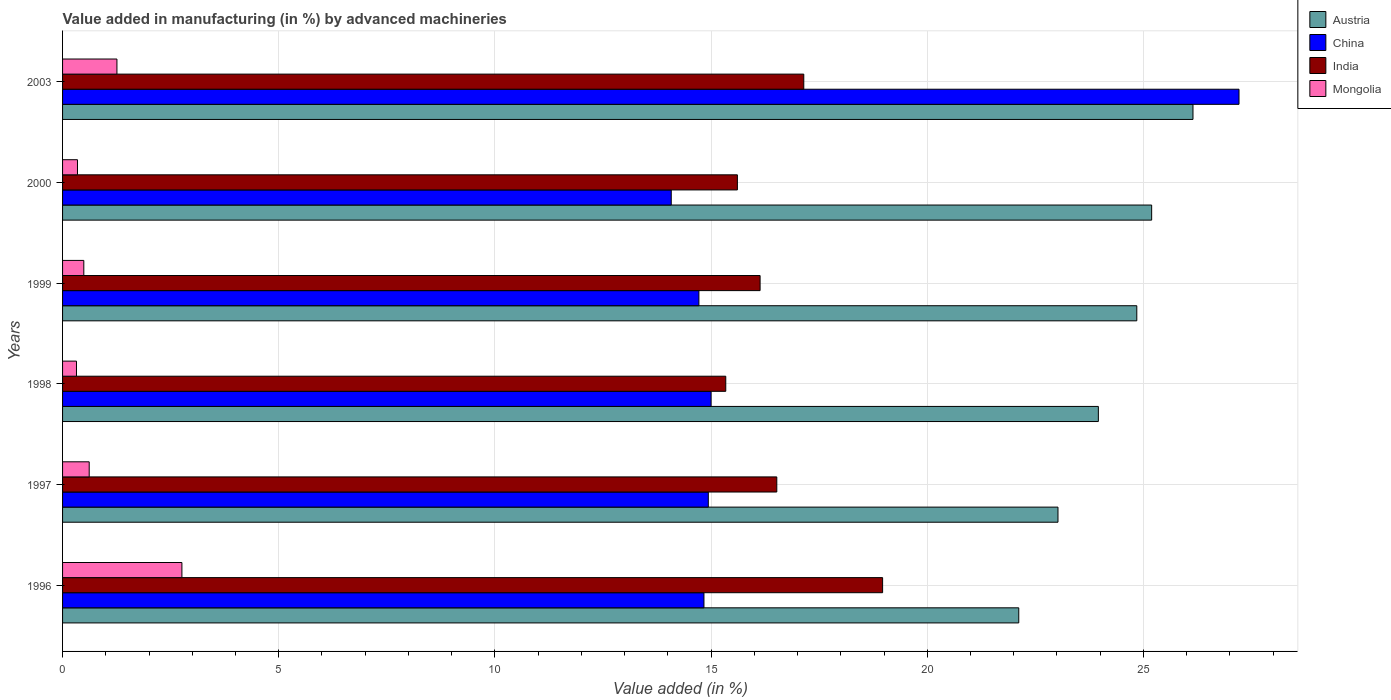How many different coloured bars are there?
Keep it short and to the point. 4. Are the number of bars on each tick of the Y-axis equal?
Provide a succinct answer. Yes. How many bars are there on the 4th tick from the top?
Offer a terse response. 4. What is the percentage of value added in manufacturing by advanced machineries in India in 1998?
Provide a succinct answer. 15.34. Across all years, what is the maximum percentage of value added in manufacturing by advanced machineries in Austria?
Give a very brief answer. 26.15. Across all years, what is the minimum percentage of value added in manufacturing by advanced machineries in India?
Give a very brief answer. 15.34. In which year was the percentage of value added in manufacturing by advanced machineries in China maximum?
Ensure brevity in your answer.  2003. What is the total percentage of value added in manufacturing by advanced machineries in Austria in the graph?
Provide a short and direct response. 145.28. What is the difference between the percentage of value added in manufacturing by advanced machineries in Austria in 1996 and that in 1997?
Your response must be concise. -0.91. What is the difference between the percentage of value added in manufacturing by advanced machineries in China in 2000 and the percentage of value added in manufacturing by advanced machineries in Mongolia in 1999?
Your answer should be compact. 13.59. What is the average percentage of value added in manufacturing by advanced machineries in Mongolia per year?
Provide a short and direct response. 0.97. In the year 1999, what is the difference between the percentage of value added in manufacturing by advanced machineries in Austria and percentage of value added in manufacturing by advanced machineries in India?
Offer a very short reply. 8.71. In how many years, is the percentage of value added in manufacturing by advanced machineries in China greater than 9 %?
Your answer should be compact. 6. What is the ratio of the percentage of value added in manufacturing by advanced machineries in Austria in 1998 to that in 2000?
Your response must be concise. 0.95. What is the difference between the highest and the second highest percentage of value added in manufacturing by advanced machineries in Austria?
Provide a succinct answer. 0.96. What is the difference between the highest and the lowest percentage of value added in manufacturing by advanced machineries in China?
Offer a terse response. 13.13. Is the sum of the percentage of value added in manufacturing by advanced machineries in China in 1997 and 1999 greater than the maximum percentage of value added in manufacturing by advanced machineries in Mongolia across all years?
Your response must be concise. Yes. What does the 1st bar from the top in 1998 represents?
Offer a very short reply. Mongolia. Are all the bars in the graph horizontal?
Provide a short and direct response. Yes. Does the graph contain any zero values?
Offer a very short reply. No. Does the graph contain grids?
Make the answer very short. Yes. Where does the legend appear in the graph?
Make the answer very short. Top right. How are the legend labels stacked?
Keep it short and to the point. Vertical. What is the title of the graph?
Offer a very short reply. Value added in manufacturing (in %) by advanced machineries. Does "Poland" appear as one of the legend labels in the graph?
Offer a terse response. No. What is the label or title of the X-axis?
Keep it short and to the point. Value added (in %). What is the Value added (in %) of Austria in 1996?
Offer a very short reply. 22.12. What is the Value added (in %) of China in 1996?
Offer a very short reply. 14.84. What is the Value added (in %) of India in 1996?
Make the answer very short. 18.97. What is the Value added (in %) of Mongolia in 1996?
Ensure brevity in your answer.  2.76. What is the Value added (in %) in Austria in 1997?
Keep it short and to the point. 23.02. What is the Value added (in %) in China in 1997?
Make the answer very short. 14.94. What is the Value added (in %) of India in 1997?
Your answer should be compact. 16.52. What is the Value added (in %) in Mongolia in 1997?
Your response must be concise. 0.62. What is the Value added (in %) of Austria in 1998?
Give a very brief answer. 23.96. What is the Value added (in %) of China in 1998?
Offer a very short reply. 15. What is the Value added (in %) in India in 1998?
Give a very brief answer. 15.34. What is the Value added (in %) in Mongolia in 1998?
Make the answer very short. 0.32. What is the Value added (in %) in Austria in 1999?
Give a very brief answer. 24.85. What is the Value added (in %) of China in 1999?
Offer a very short reply. 14.72. What is the Value added (in %) of India in 1999?
Offer a terse response. 16.13. What is the Value added (in %) of Mongolia in 1999?
Keep it short and to the point. 0.49. What is the Value added (in %) of Austria in 2000?
Offer a terse response. 25.19. What is the Value added (in %) in China in 2000?
Offer a terse response. 14.08. What is the Value added (in %) of India in 2000?
Ensure brevity in your answer.  15.61. What is the Value added (in %) of Mongolia in 2000?
Make the answer very short. 0.34. What is the Value added (in %) in Austria in 2003?
Your answer should be very brief. 26.15. What is the Value added (in %) of China in 2003?
Provide a short and direct response. 27.21. What is the Value added (in %) of India in 2003?
Offer a terse response. 17.14. What is the Value added (in %) of Mongolia in 2003?
Your answer should be compact. 1.26. Across all years, what is the maximum Value added (in %) in Austria?
Your answer should be very brief. 26.15. Across all years, what is the maximum Value added (in %) in China?
Your answer should be compact. 27.21. Across all years, what is the maximum Value added (in %) in India?
Keep it short and to the point. 18.97. Across all years, what is the maximum Value added (in %) in Mongolia?
Make the answer very short. 2.76. Across all years, what is the minimum Value added (in %) of Austria?
Keep it short and to the point. 22.12. Across all years, what is the minimum Value added (in %) in China?
Your answer should be very brief. 14.08. Across all years, what is the minimum Value added (in %) in India?
Keep it short and to the point. 15.34. Across all years, what is the minimum Value added (in %) in Mongolia?
Offer a terse response. 0.32. What is the total Value added (in %) in Austria in the graph?
Ensure brevity in your answer.  145.28. What is the total Value added (in %) of China in the graph?
Your response must be concise. 100.78. What is the total Value added (in %) of India in the graph?
Provide a short and direct response. 99.72. What is the total Value added (in %) in Mongolia in the graph?
Your answer should be compact. 5.79. What is the difference between the Value added (in %) in Austria in 1996 and that in 1997?
Give a very brief answer. -0.91. What is the difference between the Value added (in %) of China in 1996 and that in 1997?
Provide a short and direct response. -0.1. What is the difference between the Value added (in %) in India in 1996 and that in 1997?
Give a very brief answer. 2.45. What is the difference between the Value added (in %) of Mongolia in 1996 and that in 1997?
Offer a terse response. 2.14. What is the difference between the Value added (in %) of Austria in 1996 and that in 1998?
Your answer should be very brief. -1.84. What is the difference between the Value added (in %) in China in 1996 and that in 1998?
Keep it short and to the point. -0.17. What is the difference between the Value added (in %) of India in 1996 and that in 1998?
Offer a terse response. 3.63. What is the difference between the Value added (in %) in Mongolia in 1996 and that in 1998?
Your response must be concise. 2.44. What is the difference between the Value added (in %) of Austria in 1996 and that in 1999?
Offer a terse response. -2.73. What is the difference between the Value added (in %) in China in 1996 and that in 1999?
Provide a succinct answer. 0.12. What is the difference between the Value added (in %) of India in 1996 and that in 1999?
Provide a succinct answer. 2.83. What is the difference between the Value added (in %) in Mongolia in 1996 and that in 1999?
Your answer should be compact. 2.27. What is the difference between the Value added (in %) in Austria in 1996 and that in 2000?
Give a very brief answer. -3.07. What is the difference between the Value added (in %) in China in 1996 and that in 2000?
Offer a very short reply. 0.76. What is the difference between the Value added (in %) of India in 1996 and that in 2000?
Make the answer very short. 3.36. What is the difference between the Value added (in %) in Mongolia in 1996 and that in 2000?
Make the answer very short. 2.42. What is the difference between the Value added (in %) in Austria in 1996 and that in 2003?
Ensure brevity in your answer.  -4.03. What is the difference between the Value added (in %) of China in 1996 and that in 2003?
Give a very brief answer. -12.38. What is the difference between the Value added (in %) of India in 1996 and that in 2003?
Keep it short and to the point. 1.82. What is the difference between the Value added (in %) in Mongolia in 1996 and that in 2003?
Your answer should be very brief. 1.5. What is the difference between the Value added (in %) of Austria in 1997 and that in 1998?
Provide a short and direct response. -0.93. What is the difference between the Value added (in %) in China in 1997 and that in 1998?
Give a very brief answer. -0.06. What is the difference between the Value added (in %) in India in 1997 and that in 1998?
Provide a short and direct response. 1.18. What is the difference between the Value added (in %) of Mongolia in 1997 and that in 1998?
Provide a short and direct response. 0.29. What is the difference between the Value added (in %) of Austria in 1997 and that in 1999?
Offer a very short reply. -1.82. What is the difference between the Value added (in %) in China in 1997 and that in 1999?
Offer a terse response. 0.22. What is the difference between the Value added (in %) in India in 1997 and that in 1999?
Offer a terse response. 0.39. What is the difference between the Value added (in %) in Mongolia in 1997 and that in 1999?
Provide a succinct answer. 0.12. What is the difference between the Value added (in %) of Austria in 1997 and that in 2000?
Keep it short and to the point. -2.17. What is the difference between the Value added (in %) in China in 1997 and that in 2000?
Keep it short and to the point. 0.86. What is the difference between the Value added (in %) of India in 1997 and that in 2000?
Give a very brief answer. 0.91. What is the difference between the Value added (in %) of Mongolia in 1997 and that in 2000?
Provide a succinct answer. 0.27. What is the difference between the Value added (in %) of Austria in 1997 and that in 2003?
Offer a very short reply. -3.12. What is the difference between the Value added (in %) of China in 1997 and that in 2003?
Provide a short and direct response. -12.28. What is the difference between the Value added (in %) in India in 1997 and that in 2003?
Keep it short and to the point. -0.62. What is the difference between the Value added (in %) in Mongolia in 1997 and that in 2003?
Give a very brief answer. -0.64. What is the difference between the Value added (in %) of Austria in 1998 and that in 1999?
Your answer should be compact. -0.89. What is the difference between the Value added (in %) in China in 1998 and that in 1999?
Give a very brief answer. 0.28. What is the difference between the Value added (in %) in India in 1998 and that in 1999?
Ensure brevity in your answer.  -0.79. What is the difference between the Value added (in %) in Mongolia in 1998 and that in 1999?
Offer a very short reply. -0.17. What is the difference between the Value added (in %) in Austria in 1998 and that in 2000?
Ensure brevity in your answer.  -1.23. What is the difference between the Value added (in %) in China in 1998 and that in 2000?
Your answer should be very brief. 0.92. What is the difference between the Value added (in %) in India in 1998 and that in 2000?
Give a very brief answer. -0.27. What is the difference between the Value added (in %) in Mongolia in 1998 and that in 2000?
Keep it short and to the point. -0.02. What is the difference between the Value added (in %) of Austria in 1998 and that in 2003?
Ensure brevity in your answer.  -2.19. What is the difference between the Value added (in %) in China in 1998 and that in 2003?
Ensure brevity in your answer.  -12.21. What is the difference between the Value added (in %) in India in 1998 and that in 2003?
Provide a succinct answer. -1.8. What is the difference between the Value added (in %) of Mongolia in 1998 and that in 2003?
Provide a succinct answer. -0.94. What is the difference between the Value added (in %) of Austria in 1999 and that in 2000?
Keep it short and to the point. -0.34. What is the difference between the Value added (in %) of China in 1999 and that in 2000?
Ensure brevity in your answer.  0.64. What is the difference between the Value added (in %) in India in 1999 and that in 2000?
Keep it short and to the point. 0.53. What is the difference between the Value added (in %) in Mongolia in 1999 and that in 2000?
Your answer should be compact. 0.15. What is the difference between the Value added (in %) of Austria in 1999 and that in 2003?
Give a very brief answer. -1.3. What is the difference between the Value added (in %) in China in 1999 and that in 2003?
Provide a succinct answer. -12.49. What is the difference between the Value added (in %) of India in 1999 and that in 2003?
Your answer should be very brief. -1.01. What is the difference between the Value added (in %) of Mongolia in 1999 and that in 2003?
Offer a very short reply. -0.77. What is the difference between the Value added (in %) of Austria in 2000 and that in 2003?
Give a very brief answer. -0.96. What is the difference between the Value added (in %) in China in 2000 and that in 2003?
Make the answer very short. -13.13. What is the difference between the Value added (in %) of India in 2000 and that in 2003?
Give a very brief answer. -1.54. What is the difference between the Value added (in %) of Mongolia in 2000 and that in 2003?
Offer a terse response. -0.91. What is the difference between the Value added (in %) of Austria in 1996 and the Value added (in %) of China in 1997?
Offer a very short reply. 7.18. What is the difference between the Value added (in %) in Austria in 1996 and the Value added (in %) in India in 1997?
Your answer should be compact. 5.6. What is the difference between the Value added (in %) in Austria in 1996 and the Value added (in %) in Mongolia in 1997?
Provide a succinct answer. 21.5. What is the difference between the Value added (in %) of China in 1996 and the Value added (in %) of India in 1997?
Keep it short and to the point. -1.68. What is the difference between the Value added (in %) of China in 1996 and the Value added (in %) of Mongolia in 1997?
Offer a very short reply. 14.22. What is the difference between the Value added (in %) in India in 1996 and the Value added (in %) in Mongolia in 1997?
Provide a short and direct response. 18.35. What is the difference between the Value added (in %) of Austria in 1996 and the Value added (in %) of China in 1998?
Your response must be concise. 7.12. What is the difference between the Value added (in %) in Austria in 1996 and the Value added (in %) in India in 1998?
Your answer should be very brief. 6.78. What is the difference between the Value added (in %) in Austria in 1996 and the Value added (in %) in Mongolia in 1998?
Give a very brief answer. 21.8. What is the difference between the Value added (in %) of China in 1996 and the Value added (in %) of India in 1998?
Keep it short and to the point. -0.5. What is the difference between the Value added (in %) in China in 1996 and the Value added (in %) in Mongolia in 1998?
Offer a very short reply. 14.51. What is the difference between the Value added (in %) in India in 1996 and the Value added (in %) in Mongolia in 1998?
Ensure brevity in your answer.  18.65. What is the difference between the Value added (in %) of Austria in 1996 and the Value added (in %) of China in 1999?
Your response must be concise. 7.4. What is the difference between the Value added (in %) in Austria in 1996 and the Value added (in %) in India in 1999?
Offer a terse response. 5.98. What is the difference between the Value added (in %) of Austria in 1996 and the Value added (in %) of Mongolia in 1999?
Provide a short and direct response. 21.63. What is the difference between the Value added (in %) in China in 1996 and the Value added (in %) in India in 1999?
Offer a terse response. -1.3. What is the difference between the Value added (in %) of China in 1996 and the Value added (in %) of Mongolia in 1999?
Ensure brevity in your answer.  14.34. What is the difference between the Value added (in %) in India in 1996 and the Value added (in %) in Mongolia in 1999?
Keep it short and to the point. 18.48. What is the difference between the Value added (in %) of Austria in 1996 and the Value added (in %) of China in 2000?
Keep it short and to the point. 8.04. What is the difference between the Value added (in %) in Austria in 1996 and the Value added (in %) in India in 2000?
Ensure brevity in your answer.  6.51. What is the difference between the Value added (in %) of Austria in 1996 and the Value added (in %) of Mongolia in 2000?
Provide a short and direct response. 21.77. What is the difference between the Value added (in %) of China in 1996 and the Value added (in %) of India in 2000?
Give a very brief answer. -0.77. What is the difference between the Value added (in %) of China in 1996 and the Value added (in %) of Mongolia in 2000?
Your answer should be very brief. 14.49. What is the difference between the Value added (in %) in India in 1996 and the Value added (in %) in Mongolia in 2000?
Make the answer very short. 18.62. What is the difference between the Value added (in %) in Austria in 1996 and the Value added (in %) in China in 2003?
Make the answer very short. -5.09. What is the difference between the Value added (in %) of Austria in 1996 and the Value added (in %) of India in 2003?
Ensure brevity in your answer.  4.97. What is the difference between the Value added (in %) in Austria in 1996 and the Value added (in %) in Mongolia in 2003?
Make the answer very short. 20.86. What is the difference between the Value added (in %) of China in 1996 and the Value added (in %) of India in 2003?
Provide a short and direct response. -2.31. What is the difference between the Value added (in %) of China in 1996 and the Value added (in %) of Mongolia in 2003?
Your answer should be compact. 13.58. What is the difference between the Value added (in %) of India in 1996 and the Value added (in %) of Mongolia in 2003?
Provide a short and direct response. 17.71. What is the difference between the Value added (in %) in Austria in 1997 and the Value added (in %) in China in 1998?
Provide a succinct answer. 8.02. What is the difference between the Value added (in %) of Austria in 1997 and the Value added (in %) of India in 1998?
Your response must be concise. 7.68. What is the difference between the Value added (in %) in Austria in 1997 and the Value added (in %) in Mongolia in 1998?
Offer a terse response. 22.7. What is the difference between the Value added (in %) of China in 1997 and the Value added (in %) of India in 1998?
Your response must be concise. -0.4. What is the difference between the Value added (in %) in China in 1997 and the Value added (in %) in Mongolia in 1998?
Provide a succinct answer. 14.61. What is the difference between the Value added (in %) in India in 1997 and the Value added (in %) in Mongolia in 1998?
Make the answer very short. 16.2. What is the difference between the Value added (in %) of Austria in 1997 and the Value added (in %) of China in 1999?
Offer a terse response. 8.31. What is the difference between the Value added (in %) of Austria in 1997 and the Value added (in %) of India in 1999?
Provide a short and direct response. 6.89. What is the difference between the Value added (in %) of Austria in 1997 and the Value added (in %) of Mongolia in 1999?
Offer a terse response. 22.53. What is the difference between the Value added (in %) in China in 1997 and the Value added (in %) in India in 1999?
Provide a short and direct response. -1.2. What is the difference between the Value added (in %) in China in 1997 and the Value added (in %) in Mongolia in 1999?
Offer a very short reply. 14.44. What is the difference between the Value added (in %) in India in 1997 and the Value added (in %) in Mongolia in 1999?
Ensure brevity in your answer.  16.03. What is the difference between the Value added (in %) in Austria in 1997 and the Value added (in %) in China in 2000?
Your response must be concise. 8.95. What is the difference between the Value added (in %) of Austria in 1997 and the Value added (in %) of India in 2000?
Give a very brief answer. 7.42. What is the difference between the Value added (in %) in Austria in 1997 and the Value added (in %) in Mongolia in 2000?
Keep it short and to the point. 22.68. What is the difference between the Value added (in %) in China in 1997 and the Value added (in %) in India in 2000?
Offer a terse response. -0.67. What is the difference between the Value added (in %) of China in 1997 and the Value added (in %) of Mongolia in 2000?
Offer a terse response. 14.59. What is the difference between the Value added (in %) in India in 1997 and the Value added (in %) in Mongolia in 2000?
Provide a short and direct response. 16.18. What is the difference between the Value added (in %) of Austria in 1997 and the Value added (in %) of China in 2003?
Your response must be concise. -4.19. What is the difference between the Value added (in %) of Austria in 1997 and the Value added (in %) of India in 2003?
Provide a short and direct response. 5.88. What is the difference between the Value added (in %) in Austria in 1997 and the Value added (in %) in Mongolia in 2003?
Your answer should be very brief. 21.77. What is the difference between the Value added (in %) of China in 1997 and the Value added (in %) of India in 2003?
Make the answer very short. -2.21. What is the difference between the Value added (in %) in China in 1997 and the Value added (in %) in Mongolia in 2003?
Your answer should be very brief. 13.68. What is the difference between the Value added (in %) in India in 1997 and the Value added (in %) in Mongolia in 2003?
Give a very brief answer. 15.26. What is the difference between the Value added (in %) in Austria in 1998 and the Value added (in %) in China in 1999?
Make the answer very short. 9.24. What is the difference between the Value added (in %) in Austria in 1998 and the Value added (in %) in India in 1999?
Your answer should be compact. 7.82. What is the difference between the Value added (in %) of Austria in 1998 and the Value added (in %) of Mongolia in 1999?
Give a very brief answer. 23.47. What is the difference between the Value added (in %) in China in 1998 and the Value added (in %) in India in 1999?
Make the answer very short. -1.13. What is the difference between the Value added (in %) of China in 1998 and the Value added (in %) of Mongolia in 1999?
Make the answer very short. 14.51. What is the difference between the Value added (in %) in India in 1998 and the Value added (in %) in Mongolia in 1999?
Provide a short and direct response. 14.85. What is the difference between the Value added (in %) in Austria in 1998 and the Value added (in %) in China in 2000?
Give a very brief answer. 9.88. What is the difference between the Value added (in %) of Austria in 1998 and the Value added (in %) of India in 2000?
Provide a short and direct response. 8.35. What is the difference between the Value added (in %) of Austria in 1998 and the Value added (in %) of Mongolia in 2000?
Make the answer very short. 23.61. What is the difference between the Value added (in %) of China in 1998 and the Value added (in %) of India in 2000?
Offer a very short reply. -0.61. What is the difference between the Value added (in %) in China in 1998 and the Value added (in %) in Mongolia in 2000?
Give a very brief answer. 14.66. What is the difference between the Value added (in %) in India in 1998 and the Value added (in %) in Mongolia in 2000?
Your response must be concise. 14.99. What is the difference between the Value added (in %) of Austria in 1998 and the Value added (in %) of China in 2003?
Keep it short and to the point. -3.25. What is the difference between the Value added (in %) of Austria in 1998 and the Value added (in %) of India in 2003?
Offer a terse response. 6.81. What is the difference between the Value added (in %) in Austria in 1998 and the Value added (in %) in Mongolia in 2003?
Provide a short and direct response. 22.7. What is the difference between the Value added (in %) in China in 1998 and the Value added (in %) in India in 2003?
Make the answer very short. -2.14. What is the difference between the Value added (in %) in China in 1998 and the Value added (in %) in Mongolia in 2003?
Give a very brief answer. 13.74. What is the difference between the Value added (in %) in India in 1998 and the Value added (in %) in Mongolia in 2003?
Provide a succinct answer. 14.08. What is the difference between the Value added (in %) in Austria in 1999 and the Value added (in %) in China in 2000?
Provide a short and direct response. 10.77. What is the difference between the Value added (in %) of Austria in 1999 and the Value added (in %) of India in 2000?
Your response must be concise. 9.24. What is the difference between the Value added (in %) in Austria in 1999 and the Value added (in %) in Mongolia in 2000?
Provide a short and direct response. 24.5. What is the difference between the Value added (in %) of China in 1999 and the Value added (in %) of India in 2000?
Provide a succinct answer. -0.89. What is the difference between the Value added (in %) of China in 1999 and the Value added (in %) of Mongolia in 2000?
Your response must be concise. 14.37. What is the difference between the Value added (in %) in India in 1999 and the Value added (in %) in Mongolia in 2000?
Provide a succinct answer. 15.79. What is the difference between the Value added (in %) in Austria in 1999 and the Value added (in %) in China in 2003?
Provide a short and direct response. -2.36. What is the difference between the Value added (in %) of Austria in 1999 and the Value added (in %) of India in 2003?
Provide a short and direct response. 7.7. What is the difference between the Value added (in %) in Austria in 1999 and the Value added (in %) in Mongolia in 2003?
Ensure brevity in your answer.  23.59. What is the difference between the Value added (in %) of China in 1999 and the Value added (in %) of India in 2003?
Make the answer very short. -2.43. What is the difference between the Value added (in %) in China in 1999 and the Value added (in %) in Mongolia in 2003?
Offer a terse response. 13.46. What is the difference between the Value added (in %) in India in 1999 and the Value added (in %) in Mongolia in 2003?
Your answer should be very brief. 14.88. What is the difference between the Value added (in %) in Austria in 2000 and the Value added (in %) in China in 2003?
Offer a terse response. -2.02. What is the difference between the Value added (in %) in Austria in 2000 and the Value added (in %) in India in 2003?
Offer a very short reply. 8.05. What is the difference between the Value added (in %) of Austria in 2000 and the Value added (in %) of Mongolia in 2003?
Offer a very short reply. 23.93. What is the difference between the Value added (in %) in China in 2000 and the Value added (in %) in India in 2003?
Make the answer very short. -3.07. What is the difference between the Value added (in %) in China in 2000 and the Value added (in %) in Mongolia in 2003?
Offer a terse response. 12.82. What is the difference between the Value added (in %) of India in 2000 and the Value added (in %) of Mongolia in 2003?
Your answer should be very brief. 14.35. What is the average Value added (in %) in Austria per year?
Provide a short and direct response. 24.21. What is the average Value added (in %) of China per year?
Provide a succinct answer. 16.8. What is the average Value added (in %) in India per year?
Offer a terse response. 16.62. What is the average Value added (in %) of Mongolia per year?
Offer a terse response. 0.97. In the year 1996, what is the difference between the Value added (in %) of Austria and Value added (in %) of China?
Your answer should be very brief. 7.28. In the year 1996, what is the difference between the Value added (in %) in Austria and Value added (in %) in India?
Provide a succinct answer. 3.15. In the year 1996, what is the difference between the Value added (in %) of Austria and Value added (in %) of Mongolia?
Ensure brevity in your answer.  19.36. In the year 1996, what is the difference between the Value added (in %) of China and Value added (in %) of India?
Keep it short and to the point. -4.13. In the year 1996, what is the difference between the Value added (in %) of China and Value added (in %) of Mongolia?
Make the answer very short. 12.08. In the year 1996, what is the difference between the Value added (in %) in India and Value added (in %) in Mongolia?
Offer a very short reply. 16.21. In the year 1997, what is the difference between the Value added (in %) in Austria and Value added (in %) in China?
Your answer should be compact. 8.09. In the year 1997, what is the difference between the Value added (in %) in Austria and Value added (in %) in India?
Your answer should be very brief. 6.5. In the year 1997, what is the difference between the Value added (in %) in Austria and Value added (in %) in Mongolia?
Keep it short and to the point. 22.41. In the year 1997, what is the difference between the Value added (in %) in China and Value added (in %) in India?
Your answer should be very brief. -1.58. In the year 1997, what is the difference between the Value added (in %) of China and Value added (in %) of Mongolia?
Offer a terse response. 14.32. In the year 1997, what is the difference between the Value added (in %) of India and Value added (in %) of Mongolia?
Provide a succinct answer. 15.9. In the year 1998, what is the difference between the Value added (in %) of Austria and Value added (in %) of China?
Make the answer very short. 8.96. In the year 1998, what is the difference between the Value added (in %) of Austria and Value added (in %) of India?
Give a very brief answer. 8.62. In the year 1998, what is the difference between the Value added (in %) of Austria and Value added (in %) of Mongolia?
Give a very brief answer. 23.64. In the year 1998, what is the difference between the Value added (in %) in China and Value added (in %) in India?
Your answer should be very brief. -0.34. In the year 1998, what is the difference between the Value added (in %) in China and Value added (in %) in Mongolia?
Your response must be concise. 14.68. In the year 1998, what is the difference between the Value added (in %) of India and Value added (in %) of Mongolia?
Provide a succinct answer. 15.02. In the year 1999, what is the difference between the Value added (in %) of Austria and Value added (in %) of China?
Your answer should be very brief. 10.13. In the year 1999, what is the difference between the Value added (in %) of Austria and Value added (in %) of India?
Offer a terse response. 8.71. In the year 1999, what is the difference between the Value added (in %) of Austria and Value added (in %) of Mongolia?
Your answer should be compact. 24.36. In the year 1999, what is the difference between the Value added (in %) in China and Value added (in %) in India?
Offer a terse response. -1.42. In the year 1999, what is the difference between the Value added (in %) of China and Value added (in %) of Mongolia?
Your answer should be very brief. 14.23. In the year 1999, what is the difference between the Value added (in %) of India and Value added (in %) of Mongolia?
Provide a succinct answer. 15.64. In the year 2000, what is the difference between the Value added (in %) in Austria and Value added (in %) in China?
Your response must be concise. 11.11. In the year 2000, what is the difference between the Value added (in %) of Austria and Value added (in %) of India?
Give a very brief answer. 9.58. In the year 2000, what is the difference between the Value added (in %) in Austria and Value added (in %) in Mongolia?
Keep it short and to the point. 24.85. In the year 2000, what is the difference between the Value added (in %) in China and Value added (in %) in India?
Keep it short and to the point. -1.53. In the year 2000, what is the difference between the Value added (in %) of China and Value added (in %) of Mongolia?
Make the answer very short. 13.73. In the year 2000, what is the difference between the Value added (in %) in India and Value added (in %) in Mongolia?
Give a very brief answer. 15.26. In the year 2003, what is the difference between the Value added (in %) of Austria and Value added (in %) of China?
Provide a short and direct response. -1.06. In the year 2003, what is the difference between the Value added (in %) of Austria and Value added (in %) of India?
Offer a terse response. 9. In the year 2003, what is the difference between the Value added (in %) in Austria and Value added (in %) in Mongolia?
Offer a terse response. 24.89. In the year 2003, what is the difference between the Value added (in %) in China and Value added (in %) in India?
Offer a terse response. 10.07. In the year 2003, what is the difference between the Value added (in %) of China and Value added (in %) of Mongolia?
Ensure brevity in your answer.  25.95. In the year 2003, what is the difference between the Value added (in %) in India and Value added (in %) in Mongolia?
Offer a terse response. 15.89. What is the ratio of the Value added (in %) of Austria in 1996 to that in 1997?
Offer a very short reply. 0.96. What is the ratio of the Value added (in %) in India in 1996 to that in 1997?
Your answer should be compact. 1.15. What is the ratio of the Value added (in %) of Mongolia in 1996 to that in 1997?
Your response must be concise. 4.48. What is the ratio of the Value added (in %) of Austria in 1996 to that in 1998?
Your response must be concise. 0.92. What is the ratio of the Value added (in %) of China in 1996 to that in 1998?
Give a very brief answer. 0.99. What is the ratio of the Value added (in %) in India in 1996 to that in 1998?
Offer a very short reply. 1.24. What is the ratio of the Value added (in %) of Mongolia in 1996 to that in 1998?
Your answer should be very brief. 8.57. What is the ratio of the Value added (in %) of Austria in 1996 to that in 1999?
Your answer should be compact. 0.89. What is the ratio of the Value added (in %) of China in 1996 to that in 1999?
Offer a very short reply. 1.01. What is the ratio of the Value added (in %) in India in 1996 to that in 1999?
Your response must be concise. 1.18. What is the ratio of the Value added (in %) of Mongolia in 1996 to that in 1999?
Ensure brevity in your answer.  5.62. What is the ratio of the Value added (in %) of Austria in 1996 to that in 2000?
Make the answer very short. 0.88. What is the ratio of the Value added (in %) of China in 1996 to that in 2000?
Make the answer very short. 1.05. What is the ratio of the Value added (in %) of India in 1996 to that in 2000?
Your answer should be compact. 1.22. What is the ratio of the Value added (in %) of Mongolia in 1996 to that in 2000?
Ensure brevity in your answer.  8. What is the ratio of the Value added (in %) of Austria in 1996 to that in 2003?
Make the answer very short. 0.85. What is the ratio of the Value added (in %) of China in 1996 to that in 2003?
Your response must be concise. 0.55. What is the ratio of the Value added (in %) in India in 1996 to that in 2003?
Your answer should be very brief. 1.11. What is the ratio of the Value added (in %) of Mongolia in 1996 to that in 2003?
Make the answer very short. 2.19. What is the ratio of the Value added (in %) of China in 1997 to that in 1998?
Offer a very short reply. 1. What is the ratio of the Value added (in %) of India in 1997 to that in 1998?
Your answer should be compact. 1.08. What is the ratio of the Value added (in %) in Mongolia in 1997 to that in 1998?
Offer a terse response. 1.91. What is the ratio of the Value added (in %) in Austria in 1997 to that in 1999?
Keep it short and to the point. 0.93. What is the ratio of the Value added (in %) of China in 1997 to that in 1999?
Give a very brief answer. 1.01. What is the ratio of the Value added (in %) of India in 1997 to that in 1999?
Make the answer very short. 1.02. What is the ratio of the Value added (in %) of Mongolia in 1997 to that in 1999?
Ensure brevity in your answer.  1.25. What is the ratio of the Value added (in %) of Austria in 1997 to that in 2000?
Keep it short and to the point. 0.91. What is the ratio of the Value added (in %) of China in 1997 to that in 2000?
Offer a very short reply. 1.06. What is the ratio of the Value added (in %) in India in 1997 to that in 2000?
Your answer should be compact. 1.06. What is the ratio of the Value added (in %) of Mongolia in 1997 to that in 2000?
Provide a short and direct response. 1.79. What is the ratio of the Value added (in %) of Austria in 1997 to that in 2003?
Offer a terse response. 0.88. What is the ratio of the Value added (in %) of China in 1997 to that in 2003?
Ensure brevity in your answer.  0.55. What is the ratio of the Value added (in %) of India in 1997 to that in 2003?
Your answer should be very brief. 0.96. What is the ratio of the Value added (in %) of Mongolia in 1997 to that in 2003?
Ensure brevity in your answer.  0.49. What is the ratio of the Value added (in %) of Austria in 1998 to that in 1999?
Provide a short and direct response. 0.96. What is the ratio of the Value added (in %) in China in 1998 to that in 1999?
Your answer should be compact. 1.02. What is the ratio of the Value added (in %) of India in 1998 to that in 1999?
Keep it short and to the point. 0.95. What is the ratio of the Value added (in %) in Mongolia in 1998 to that in 1999?
Keep it short and to the point. 0.66. What is the ratio of the Value added (in %) of Austria in 1998 to that in 2000?
Your answer should be compact. 0.95. What is the ratio of the Value added (in %) in China in 1998 to that in 2000?
Your answer should be very brief. 1.07. What is the ratio of the Value added (in %) in India in 1998 to that in 2000?
Keep it short and to the point. 0.98. What is the ratio of the Value added (in %) of Mongolia in 1998 to that in 2000?
Provide a succinct answer. 0.93. What is the ratio of the Value added (in %) of Austria in 1998 to that in 2003?
Ensure brevity in your answer.  0.92. What is the ratio of the Value added (in %) in China in 1998 to that in 2003?
Offer a very short reply. 0.55. What is the ratio of the Value added (in %) in India in 1998 to that in 2003?
Your answer should be very brief. 0.89. What is the ratio of the Value added (in %) of Mongolia in 1998 to that in 2003?
Keep it short and to the point. 0.26. What is the ratio of the Value added (in %) of Austria in 1999 to that in 2000?
Ensure brevity in your answer.  0.99. What is the ratio of the Value added (in %) of China in 1999 to that in 2000?
Keep it short and to the point. 1.05. What is the ratio of the Value added (in %) of India in 1999 to that in 2000?
Offer a terse response. 1.03. What is the ratio of the Value added (in %) in Mongolia in 1999 to that in 2000?
Your response must be concise. 1.42. What is the ratio of the Value added (in %) of Austria in 1999 to that in 2003?
Ensure brevity in your answer.  0.95. What is the ratio of the Value added (in %) in China in 1999 to that in 2003?
Your response must be concise. 0.54. What is the ratio of the Value added (in %) of India in 1999 to that in 2003?
Offer a terse response. 0.94. What is the ratio of the Value added (in %) of Mongolia in 1999 to that in 2003?
Provide a short and direct response. 0.39. What is the ratio of the Value added (in %) in Austria in 2000 to that in 2003?
Keep it short and to the point. 0.96. What is the ratio of the Value added (in %) in China in 2000 to that in 2003?
Keep it short and to the point. 0.52. What is the ratio of the Value added (in %) in India in 2000 to that in 2003?
Offer a terse response. 0.91. What is the ratio of the Value added (in %) of Mongolia in 2000 to that in 2003?
Offer a terse response. 0.27. What is the difference between the highest and the second highest Value added (in %) in Austria?
Your answer should be very brief. 0.96. What is the difference between the highest and the second highest Value added (in %) in China?
Ensure brevity in your answer.  12.21. What is the difference between the highest and the second highest Value added (in %) of India?
Make the answer very short. 1.82. What is the difference between the highest and the second highest Value added (in %) in Mongolia?
Provide a succinct answer. 1.5. What is the difference between the highest and the lowest Value added (in %) in Austria?
Offer a very short reply. 4.03. What is the difference between the highest and the lowest Value added (in %) of China?
Offer a very short reply. 13.13. What is the difference between the highest and the lowest Value added (in %) of India?
Offer a very short reply. 3.63. What is the difference between the highest and the lowest Value added (in %) in Mongolia?
Offer a terse response. 2.44. 